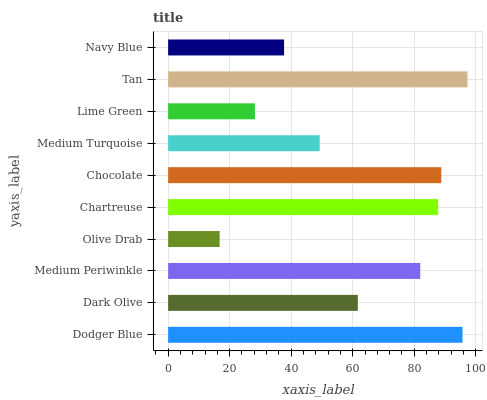Is Olive Drab the minimum?
Answer yes or no. Yes. Is Tan the maximum?
Answer yes or no. Yes. Is Dark Olive the minimum?
Answer yes or no. No. Is Dark Olive the maximum?
Answer yes or no. No. Is Dodger Blue greater than Dark Olive?
Answer yes or no. Yes. Is Dark Olive less than Dodger Blue?
Answer yes or no. Yes. Is Dark Olive greater than Dodger Blue?
Answer yes or no. No. Is Dodger Blue less than Dark Olive?
Answer yes or no. No. Is Medium Periwinkle the high median?
Answer yes or no. Yes. Is Dark Olive the low median?
Answer yes or no. Yes. Is Navy Blue the high median?
Answer yes or no. No. Is Chartreuse the low median?
Answer yes or no. No. 